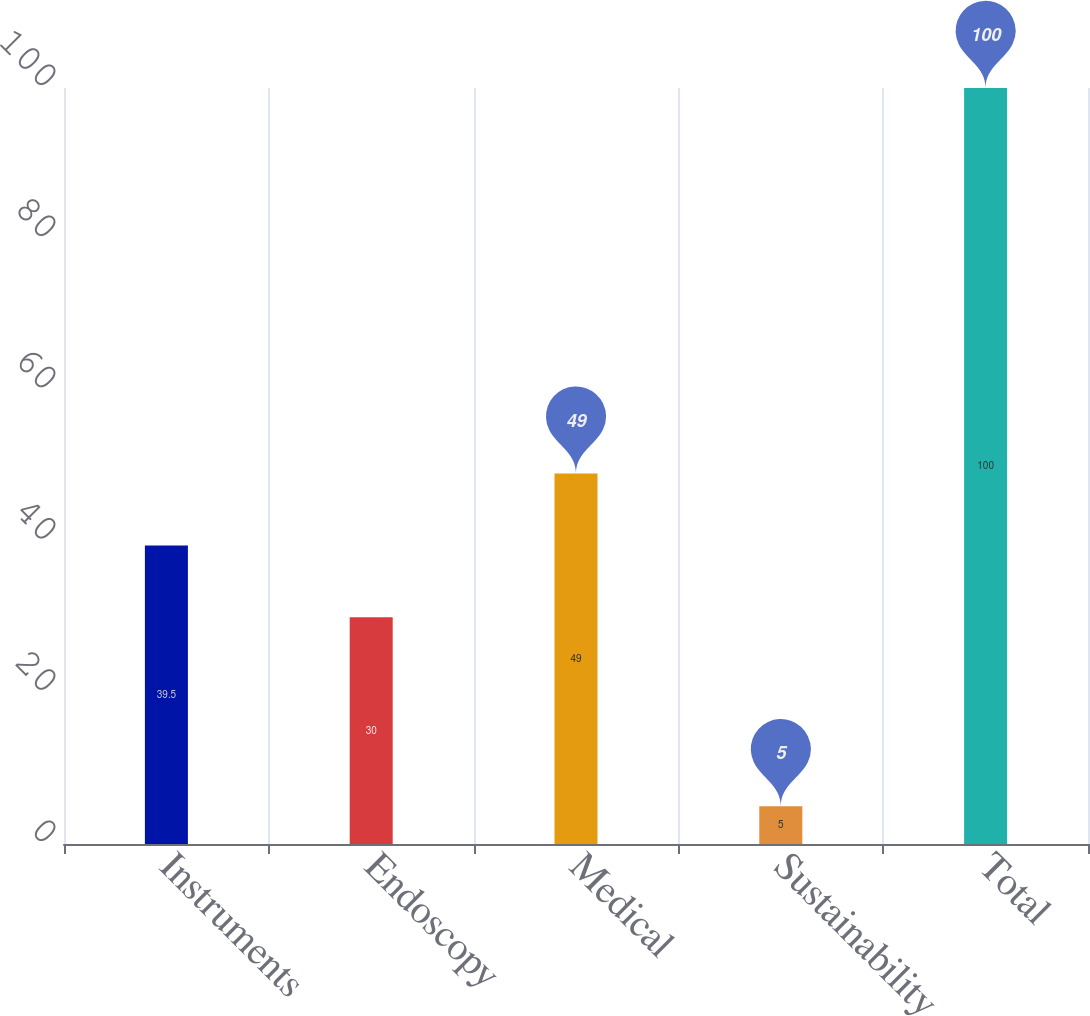Convert chart. <chart><loc_0><loc_0><loc_500><loc_500><bar_chart><fcel>Instruments<fcel>Endoscopy<fcel>Medical<fcel>Sustainability<fcel>Total<nl><fcel>39.5<fcel>30<fcel>49<fcel>5<fcel>100<nl></chart> 